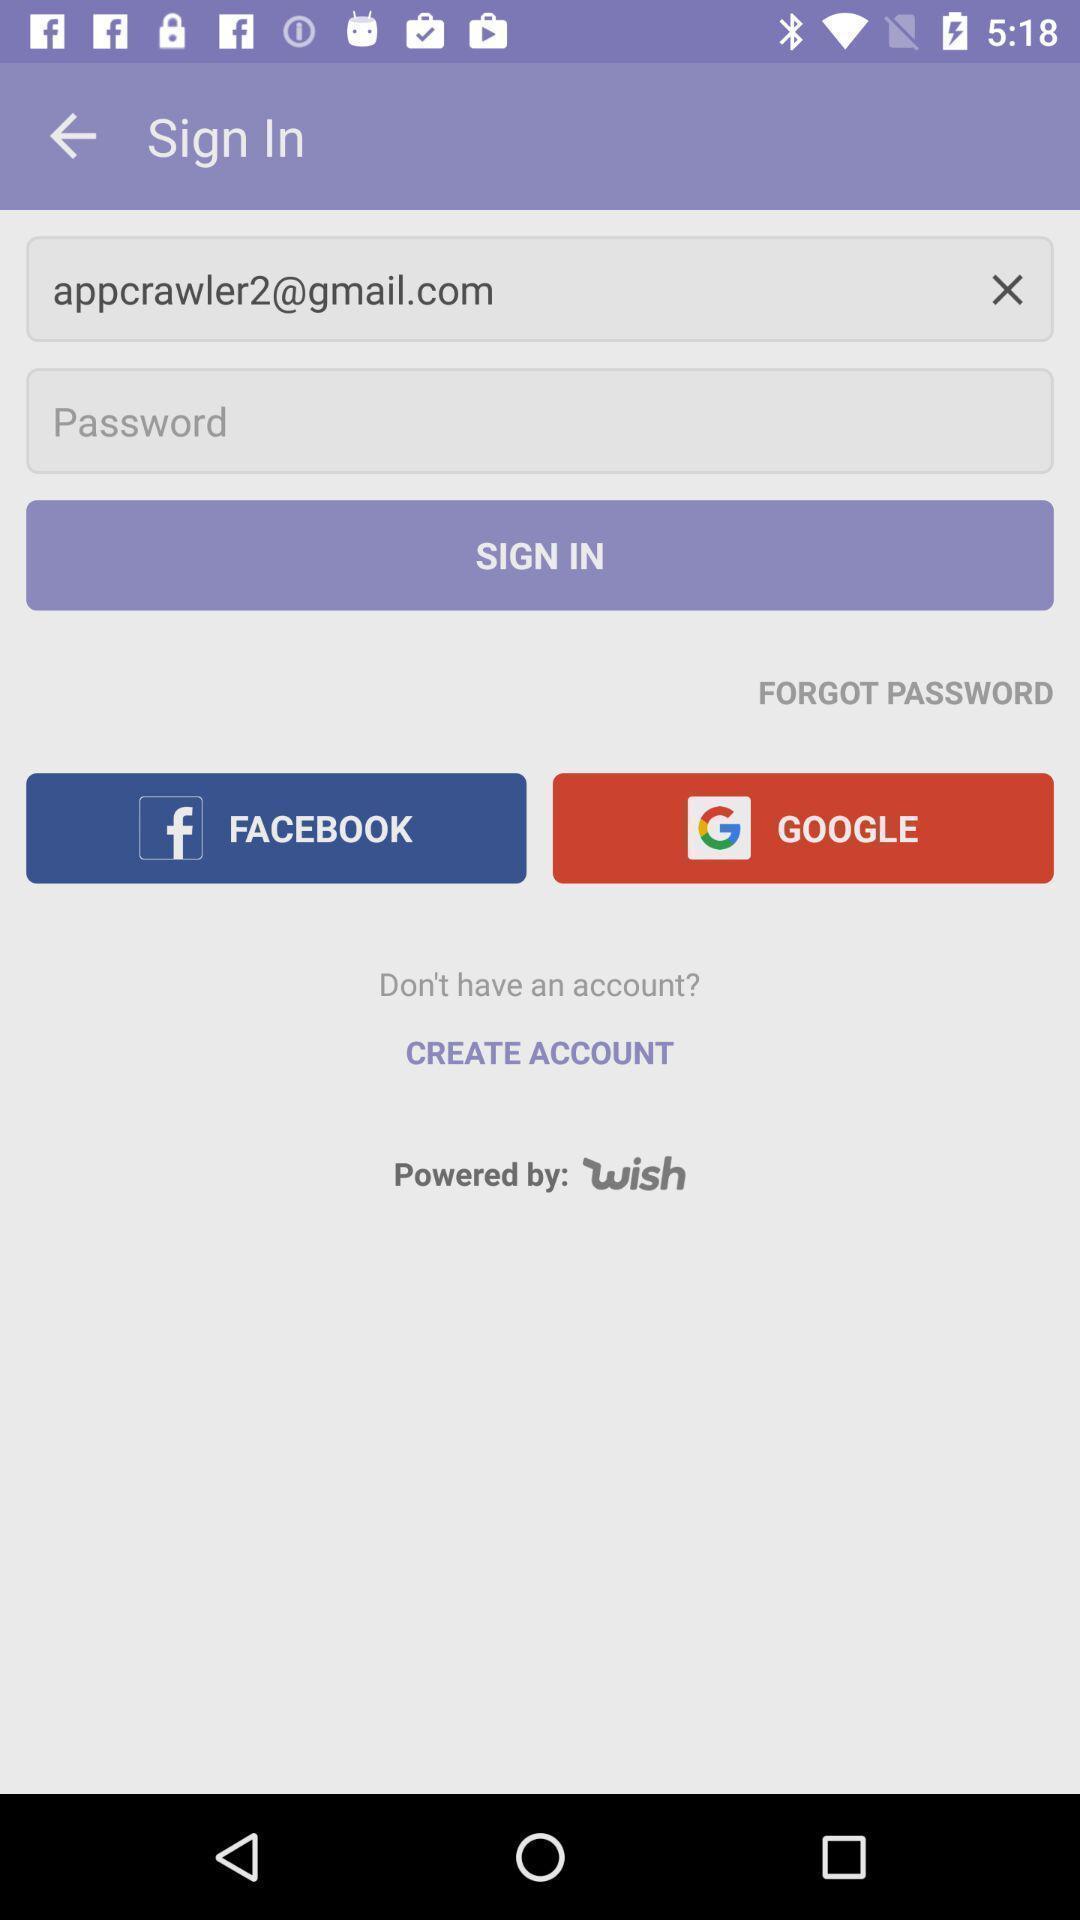Describe the visual elements of this screenshot. Sign in page of a social app. 